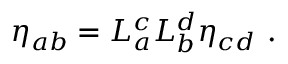<formula> <loc_0><loc_0><loc_500><loc_500>\eta _ { a b } = L _ { a } ^ { c } L _ { b } ^ { d } \eta _ { c d } .</formula> 